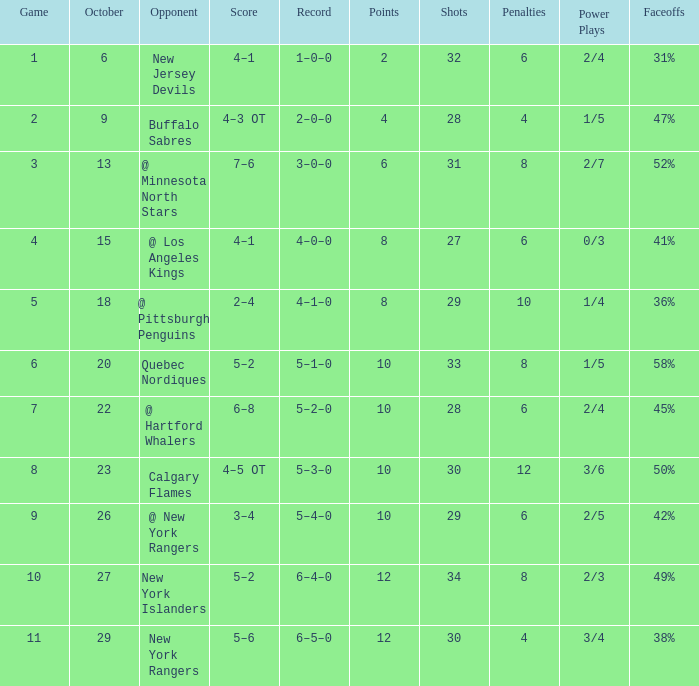Which October has a Record of 5–1–0, and a Game larger than 6? None. 